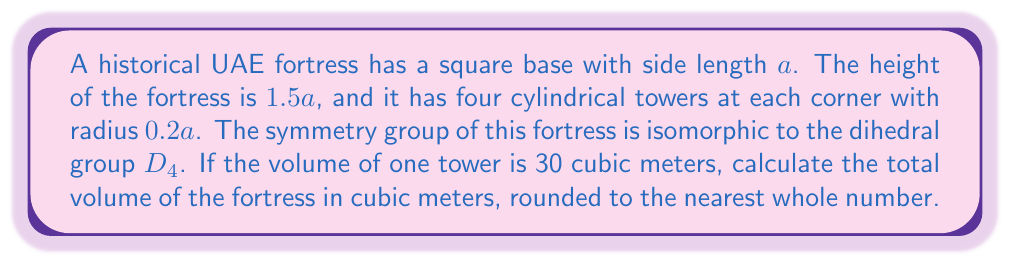Teach me how to tackle this problem. Let's approach this step-by-step:

1) First, we need to find the value of $a$. We know that the volume of one tower is 30 cubic meters.
   The volume of a cylinder is $V = \pi r^2 h$
   
   $30 = \pi (0.2a)^2 (1.5a)$
   $30 = 0.06\pi a^3$
   $a^3 = \frac{500}{\pi}$
   $a = \sqrt[3]{\frac{500}{\pi}} \approx 5.4$ meters

2) Now we can calculate the volume of the main body of the fortress:
   $V_{body} = a^2 \cdot 1.5a = 1.5a^3 = 1.5 \cdot \frac{500}{\pi} \approx 238.7$ cubic meters

3) The volume of all four towers together:
   $V_{towers} = 4 \cdot 30 = 120$ cubic meters

4) The total volume is the sum of the body and the towers:
   $V_{total} = V_{body} + V_{towers} = 238.7 + 120 = 358.7$ cubic meters

5) Rounding to the nearest whole number:
   $V_{total} \approx 359$ cubic meters

Note: The dihedral group $D_4$ represents the symmetries of a square, which aligns with the square base of the fortress. This group has 8 elements: 4 rotations (including the identity) and 4 reflections, corresponding to the symmetries of the fortress structure.
Answer: 359 cubic meters 